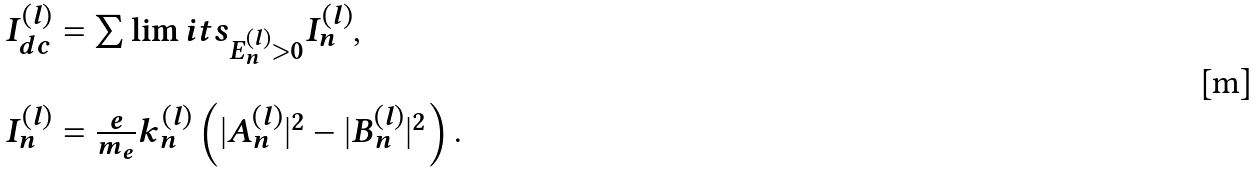Convert formula to latex. <formula><loc_0><loc_0><loc_500><loc_500>\begin{array} { l } I _ { d c } ^ { ( l ) } = \sum \lim i t s _ { E _ { n } ^ { ( l ) } > 0 } I ^ { ( l ) } _ { n } , \\ \ \\ I ^ { ( l ) } _ { n } = \frac { e } { m _ { e } } k _ { n } ^ { ( l ) } \left ( | A _ { n } ^ { ( l ) } | ^ { 2 } - | B _ { n } ^ { ( l ) } | ^ { 2 } \right ) . \end{array}</formula> 